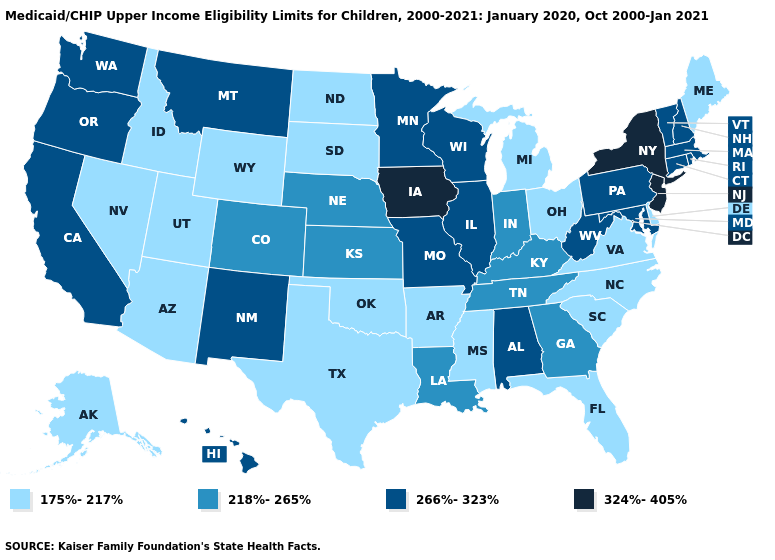Among the states that border New Hampshire , does Maine have the highest value?
Short answer required. No. What is the lowest value in the South?
Be succinct. 175%-217%. Which states have the lowest value in the Northeast?
Quick response, please. Maine. Which states hav the highest value in the Northeast?
Keep it brief. New Jersey, New York. Among the states that border Utah , which have the highest value?
Be succinct. New Mexico. What is the highest value in the West ?
Keep it brief. 266%-323%. What is the value of Utah?
Answer briefly. 175%-217%. Among the states that border Vermont , does Massachusetts have the highest value?
Give a very brief answer. No. What is the lowest value in states that border Virginia?
Be succinct. 175%-217%. What is the lowest value in the USA?
Short answer required. 175%-217%. Name the states that have a value in the range 324%-405%?
Be succinct. Iowa, New Jersey, New York. Among the states that border West Virginia , does Ohio have the lowest value?
Quick response, please. Yes. Which states hav the highest value in the MidWest?
Quick response, please. Iowa. Among the states that border North Dakota , which have the highest value?
Write a very short answer. Minnesota, Montana. Which states have the lowest value in the USA?
Be succinct. Alaska, Arizona, Arkansas, Delaware, Florida, Idaho, Maine, Michigan, Mississippi, Nevada, North Carolina, North Dakota, Ohio, Oklahoma, South Carolina, South Dakota, Texas, Utah, Virginia, Wyoming. 